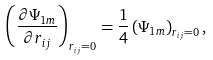Convert formula to latex. <formula><loc_0><loc_0><loc_500><loc_500>\left ( \frac { \partial \Psi _ { 1 m } } { \partial r _ { i j } } \right ) _ { r _ { i j } = 0 } = \frac { 1 } { 4 } \left ( \Psi _ { 1 m } \right ) _ { r _ { i j } = 0 } ,</formula> 